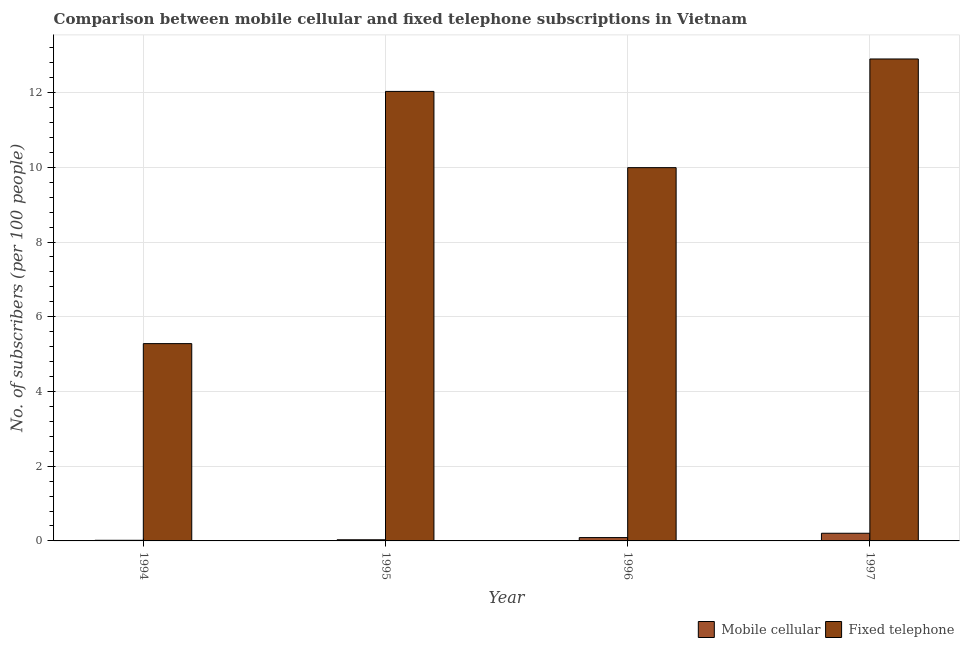How many different coloured bars are there?
Your response must be concise. 2. Are the number of bars per tick equal to the number of legend labels?
Your answer should be compact. Yes. Are the number of bars on each tick of the X-axis equal?
Your answer should be very brief. Yes. What is the number of fixed telephone subscribers in 1997?
Offer a terse response. 12.9. Across all years, what is the maximum number of mobile cellular subscribers?
Your answer should be very brief. 0.21. Across all years, what is the minimum number of mobile cellular subscribers?
Ensure brevity in your answer.  0.02. In which year was the number of mobile cellular subscribers maximum?
Your answer should be compact. 1997. What is the total number of mobile cellular subscribers in the graph?
Your response must be concise. 0.34. What is the difference between the number of fixed telephone subscribers in 1995 and that in 1996?
Provide a succinct answer. 2.04. What is the difference between the number of fixed telephone subscribers in 1997 and the number of mobile cellular subscribers in 1994?
Your answer should be very brief. 7.62. What is the average number of mobile cellular subscribers per year?
Your answer should be very brief. 0.09. What is the ratio of the number of mobile cellular subscribers in 1994 to that in 1996?
Your answer should be very brief. 0.19. What is the difference between the highest and the second highest number of mobile cellular subscribers?
Give a very brief answer. 0.12. What is the difference between the highest and the lowest number of fixed telephone subscribers?
Offer a very short reply. 7.62. What does the 2nd bar from the left in 1994 represents?
Ensure brevity in your answer.  Fixed telephone. What does the 1st bar from the right in 1997 represents?
Offer a very short reply. Fixed telephone. Are the values on the major ticks of Y-axis written in scientific E-notation?
Offer a very short reply. No. Does the graph contain any zero values?
Offer a very short reply. No. Where does the legend appear in the graph?
Provide a succinct answer. Bottom right. What is the title of the graph?
Make the answer very short. Comparison between mobile cellular and fixed telephone subscriptions in Vietnam. What is the label or title of the Y-axis?
Ensure brevity in your answer.  No. of subscribers (per 100 people). What is the No. of subscribers (per 100 people) in Mobile cellular in 1994?
Your answer should be very brief. 0.02. What is the No. of subscribers (per 100 people) of Fixed telephone in 1994?
Offer a very short reply. 5.28. What is the No. of subscribers (per 100 people) of Mobile cellular in 1995?
Make the answer very short. 0.03. What is the No. of subscribers (per 100 people) of Fixed telephone in 1995?
Offer a very short reply. 12.03. What is the No. of subscribers (per 100 people) in Mobile cellular in 1996?
Provide a short and direct response. 0.09. What is the No. of subscribers (per 100 people) in Fixed telephone in 1996?
Your answer should be compact. 9.99. What is the No. of subscribers (per 100 people) in Mobile cellular in 1997?
Your answer should be compact. 0.21. What is the No. of subscribers (per 100 people) of Fixed telephone in 1997?
Your answer should be very brief. 12.9. Across all years, what is the maximum No. of subscribers (per 100 people) in Mobile cellular?
Your answer should be very brief. 0.21. Across all years, what is the maximum No. of subscribers (per 100 people) in Fixed telephone?
Your answer should be compact. 12.9. Across all years, what is the minimum No. of subscribers (per 100 people) in Mobile cellular?
Your answer should be very brief. 0.02. Across all years, what is the minimum No. of subscribers (per 100 people) in Fixed telephone?
Give a very brief answer. 5.28. What is the total No. of subscribers (per 100 people) in Mobile cellular in the graph?
Provide a short and direct response. 0.34. What is the total No. of subscribers (per 100 people) of Fixed telephone in the graph?
Provide a succinct answer. 40.2. What is the difference between the No. of subscribers (per 100 people) in Mobile cellular in 1994 and that in 1995?
Your answer should be very brief. -0.01. What is the difference between the No. of subscribers (per 100 people) of Fixed telephone in 1994 and that in 1995?
Provide a short and direct response. -6.75. What is the difference between the No. of subscribers (per 100 people) of Mobile cellular in 1994 and that in 1996?
Provide a succinct answer. -0.07. What is the difference between the No. of subscribers (per 100 people) of Fixed telephone in 1994 and that in 1996?
Your answer should be compact. -4.71. What is the difference between the No. of subscribers (per 100 people) of Mobile cellular in 1994 and that in 1997?
Provide a short and direct response. -0.19. What is the difference between the No. of subscribers (per 100 people) in Fixed telephone in 1994 and that in 1997?
Your answer should be very brief. -7.62. What is the difference between the No. of subscribers (per 100 people) of Mobile cellular in 1995 and that in 1996?
Provide a short and direct response. -0.06. What is the difference between the No. of subscribers (per 100 people) in Fixed telephone in 1995 and that in 1996?
Ensure brevity in your answer.  2.04. What is the difference between the No. of subscribers (per 100 people) of Mobile cellular in 1995 and that in 1997?
Provide a succinct answer. -0.17. What is the difference between the No. of subscribers (per 100 people) of Fixed telephone in 1995 and that in 1997?
Give a very brief answer. -0.87. What is the difference between the No. of subscribers (per 100 people) of Mobile cellular in 1996 and that in 1997?
Provide a succinct answer. -0.12. What is the difference between the No. of subscribers (per 100 people) of Fixed telephone in 1996 and that in 1997?
Offer a very short reply. -2.91. What is the difference between the No. of subscribers (per 100 people) in Mobile cellular in 1994 and the No. of subscribers (per 100 people) in Fixed telephone in 1995?
Offer a terse response. -12.02. What is the difference between the No. of subscribers (per 100 people) of Mobile cellular in 1994 and the No. of subscribers (per 100 people) of Fixed telephone in 1996?
Give a very brief answer. -9.97. What is the difference between the No. of subscribers (per 100 people) of Mobile cellular in 1994 and the No. of subscribers (per 100 people) of Fixed telephone in 1997?
Provide a short and direct response. -12.88. What is the difference between the No. of subscribers (per 100 people) of Mobile cellular in 1995 and the No. of subscribers (per 100 people) of Fixed telephone in 1996?
Make the answer very short. -9.96. What is the difference between the No. of subscribers (per 100 people) in Mobile cellular in 1995 and the No. of subscribers (per 100 people) in Fixed telephone in 1997?
Offer a terse response. -12.87. What is the difference between the No. of subscribers (per 100 people) in Mobile cellular in 1996 and the No. of subscribers (per 100 people) in Fixed telephone in 1997?
Your response must be concise. -12.81. What is the average No. of subscribers (per 100 people) in Mobile cellular per year?
Provide a short and direct response. 0.09. What is the average No. of subscribers (per 100 people) of Fixed telephone per year?
Offer a very short reply. 10.05. In the year 1994, what is the difference between the No. of subscribers (per 100 people) in Mobile cellular and No. of subscribers (per 100 people) in Fixed telephone?
Keep it short and to the point. -5.26. In the year 1995, what is the difference between the No. of subscribers (per 100 people) of Mobile cellular and No. of subscribers (per 100 people) of Fixed telephone?
Make the answer very short. -12. In the year 1996, what is the difference between the No. of subscribers (per 100 people) in Mobile cellular and No. of subscribers (per 100 people) in Fixed telephone?
Give a very brief answer. -9.9. In the year 1997, what is the difference between the No. of subscribers (per 100 people) in Mobile cellular and No. of subscribers (per 100 people) in Fixed telephone?
Provide a short and direct response. -12.7. What is the ratio of the No. of subscribers (per 100 people) of Mobile cellular in 1994 to that in 1995?
Provide a short and direct response. 0.54. What is the ratio of the No. of subscribers (per 100 people) in Fixed telephone in 1994 to that in 1995?
Your response must be concise. 0.44. What is the ratio of the No. of subscribers (per 100 people) in Mobile cellular in 1994 to that in 1996?
Keep it short and to the point. 0.19. What is the ratio of the No. of subscribers (per 100 people) of Fixed telephone in 1994 to that in 1996?
Give a very brief answer. 0.53. What is the ratio of the No. of subscribers (per 100 people) of Mobile cellular in 1994 to that in 1997?
Keep it short and to the point. 0.08. What is the ratio of the No. of subscribers (per 100 people) in Fixed telephone in 1994 to that in 1997?
Your answer should be compact. 0.41. What is the ratio of the No. of subscribers (per 100 people) in Mobile cellular in 1995 to that in 1996?
Your answer should be compact. 0.35. What is the ratio of the No. of subscribers (per 100 people) of Fixed telephone in 1995 to that in 1996?
Provide a short and direct response. 1.2. What is the ratio of the No. of subscribers (per 100 people) of Mobile cellular in 1995 to that in 1997?
Offer a terse response. 0.15. What is the ratio of the No. of subscribers (per 100 people) of Fixed telephone in 1995 to that in 1997?
Keep it short and to the point. 0.93. What is the ratio of the No. of subscribers (per 100 people) of Mobile cellular in 1996 to that in 1997?
Keep it short and to the point. 0.44. What is the ratio of the No. of subscribers (per 100 people) of Fixed telephone in 1996 to that in 1997?
Your answer should be compact. 0.77. What is the difference between the highest and the second highest No. of subscribers (per 100 people) of Mobile cellular?
Your answer should be very brief. 0.12. What is the difference between the highest and the second highest No. of subscribers (per 100 people) of Fixed telephone?
Your answer should be compact. 0.87. What is the difference between the highest and the lowest No. of subscribers (per 100 people) of Mobile cellular?
Give a very brief answer. 0.19. What is the difference between the highest and the lowest No. of subscribers (per 100 people) in Fixed telephone?
Provide a succinct answer. 7.62. 